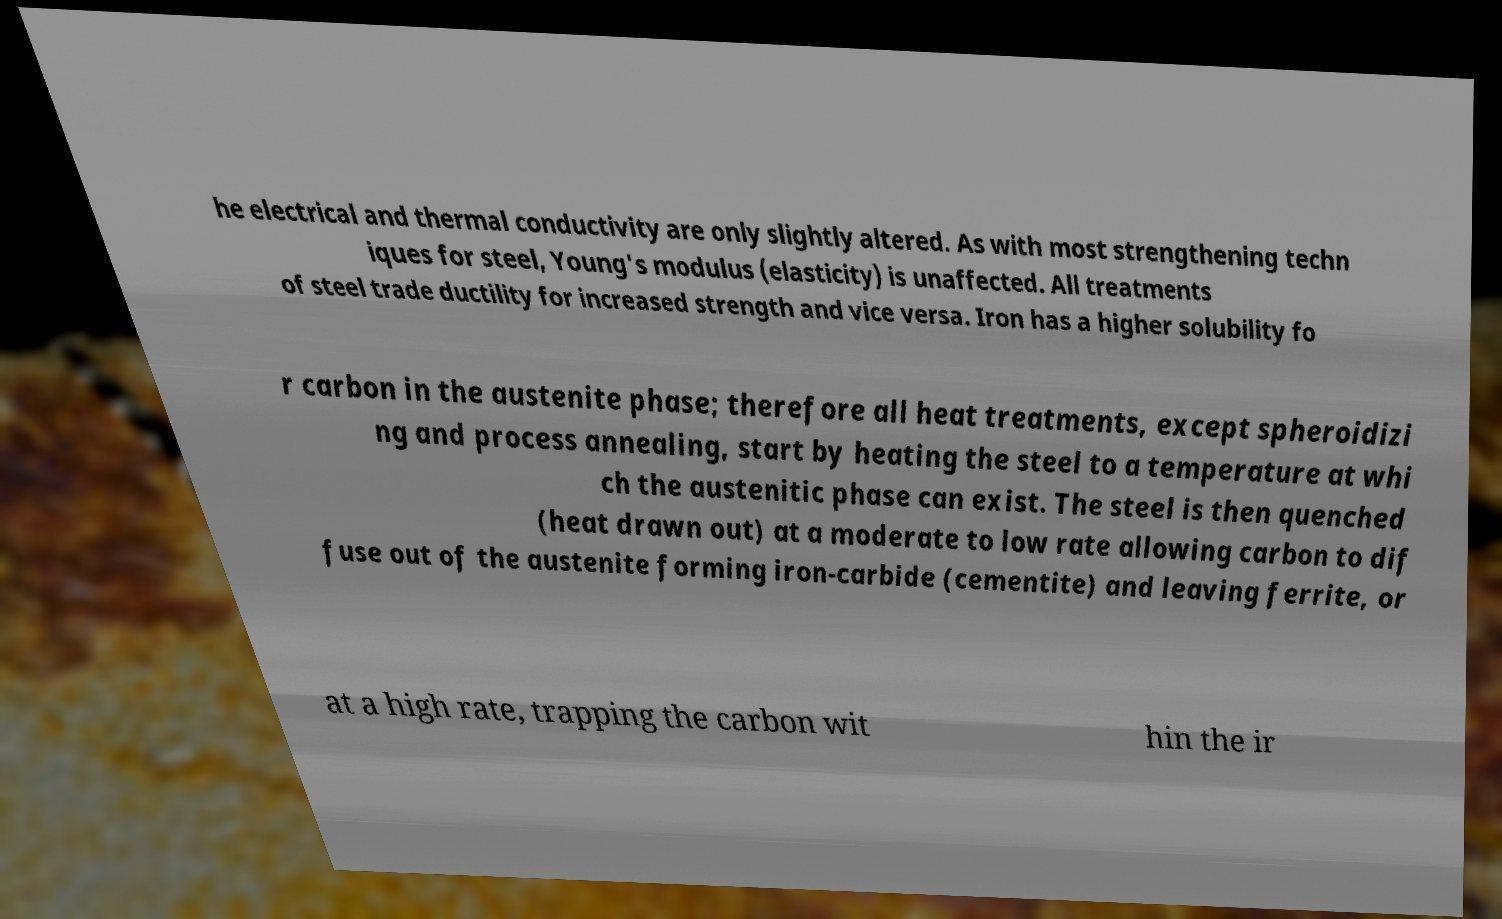Please read and relay the text visible in this image. What does it say? he electrical and thermal conductivity are only slightly altered. As with most strengthening techn iques for steel, Young's modulus (elasticity) is unaffected. All treatments of steel trade ductility for increased strength and vice versa. Iron has a higher solubility fo r carbon in the austenite phase; therefore all heat treatments, except spheroidizi ng and process annealing, start by heating the steel to a temperature at whi ch the austenitic phase can exist. The steel is then quenched (heat drawn out) at a moderate to low rate allowing carbon to dif fuse out of the austenite forming iron-carbide (cementite) and leaving ferrite, or at a high rate, trapping the carbon wit hin the ir 